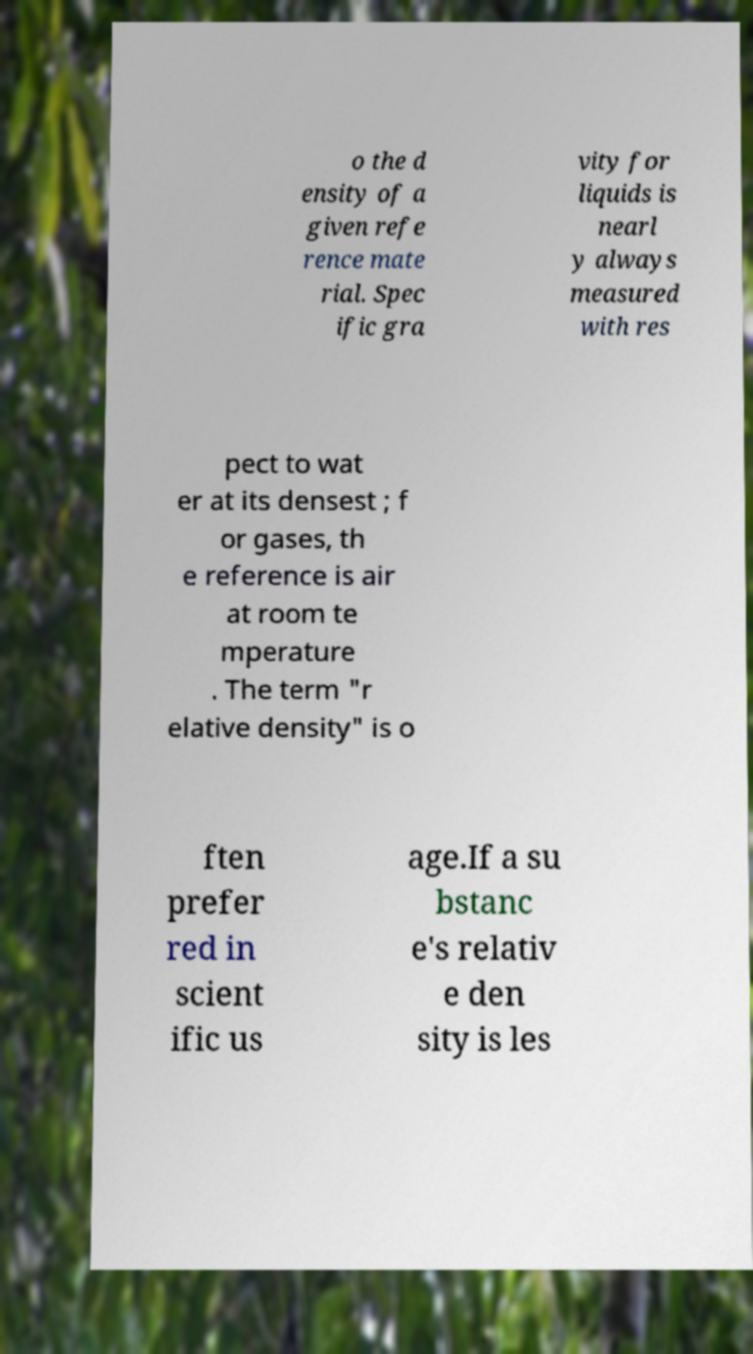Could you assist in decoding the text presented in this image and type it out clearly? o the d ensity of a given refe rence mate rial. Spec ific gra vity for liquids is nearl y always measured with res pect to wat er at its densest ; f or gases, th e reference is air at room te mperature . The term "r elative density" is o ften prefer red in scient ific us age.If a su bstanc e's relativ e den sity is les 